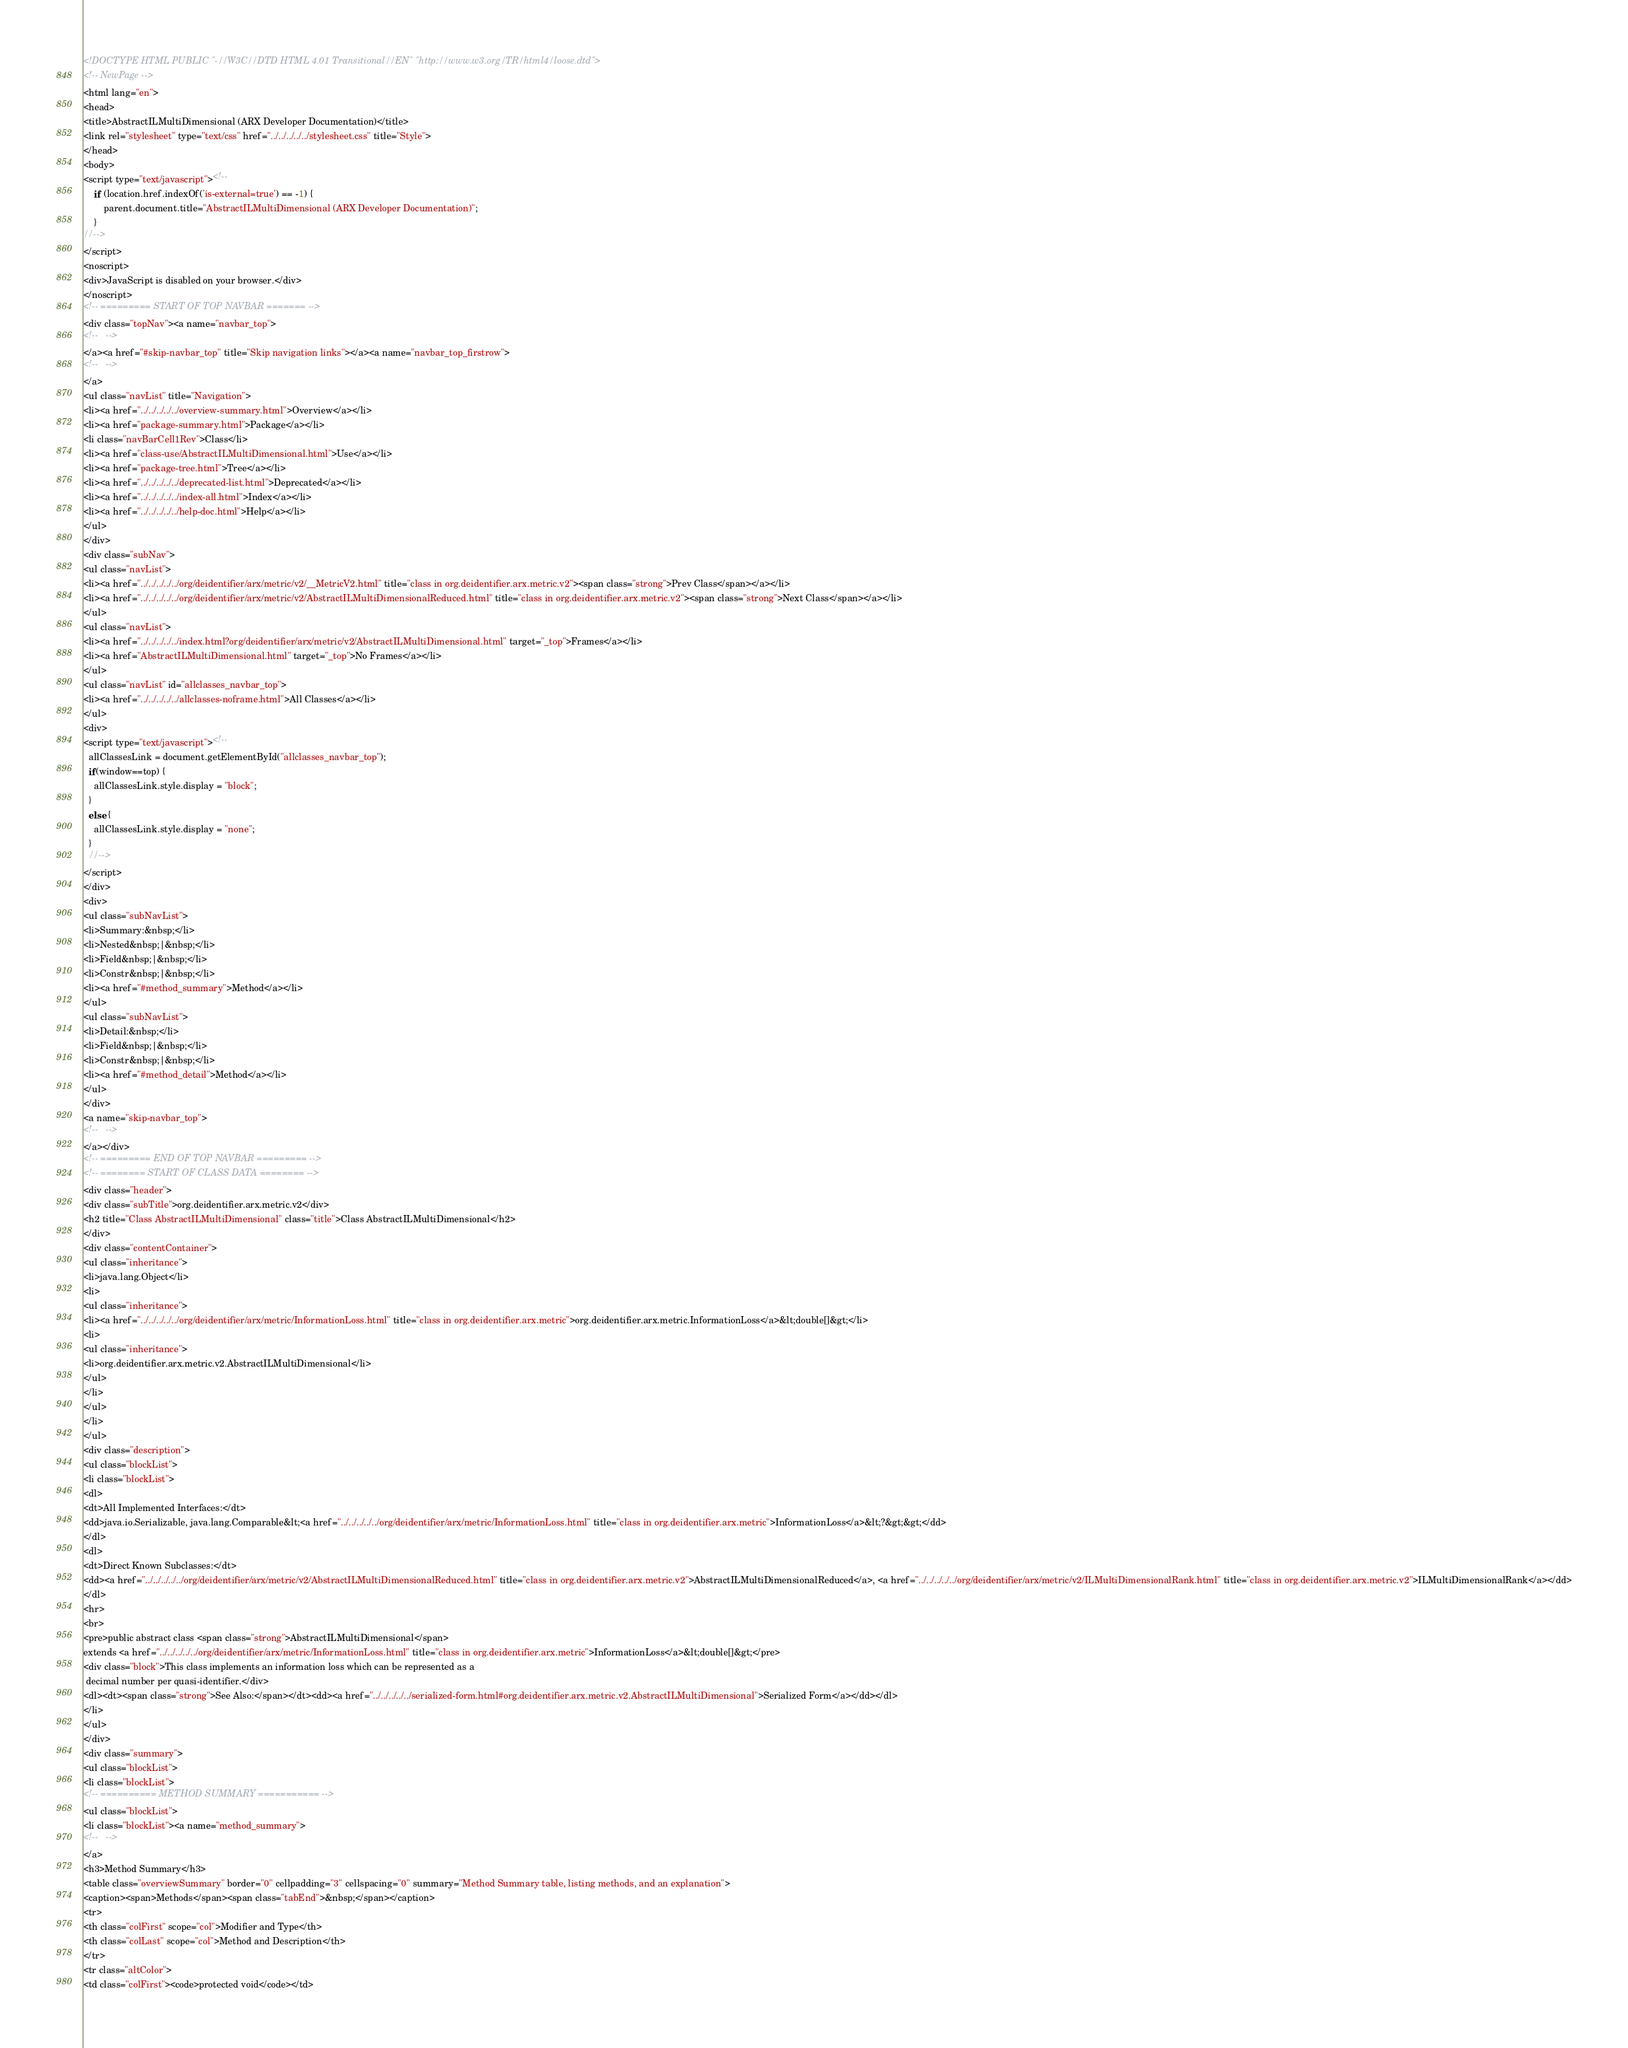<code> <loc_0><loc_0><loc_500><loc_500><_HTML_><!DOCTYPE HTML PUBLIC "-//W3C//DTD HTML 4.01 Transitional//EN" "http://www.w3.org/TR/html4/loose.dtd">
<!-- NewPage -->
<html lang="en">
<head>
<title>AbstractILMultiDimensional (ARX Developer Documentation)</title>
<link rel="stylesheet" type="text/css" href="../../../../../stylesheet.css" title="Style">
</head>
<body>
<script type="text/javascript"><!--
    if (location.href.indexOf('is-external=true') == -1) {
        parent.document.title="AbstractILMultiDimensional (ARX Developer Documentation)";
    }
//-->
</script>
<noscript>
<div>JavaScript is disabled on your browser.</div>
</noscript>
<!-- ========= START OF TOP NAVBAR ======= -->
<div class="topNav"><a name="navbar_top">
<!--   -->
</a><a href="#skip-navbar_top" title="Skip navigation links"></a><a name="navbar_top_firstrow">
<!--   -->
</a>
<ul class="navList" title="Navigation">
<li><a href="../../../../../overview-summary.html">Overview</a></li>
<li><a href="package-summary.html">Package</a></li>
<li class="navBarCell1Rev">Class</li>
<li><a href="class-use/AbstractILMultiDimensional.html">Use</a></li>
<li><a href="package-tree.html">Tree</a></li>
<li><a href="../../../../../deprecated-list.html">Deprecated</a></li>
<li><a href="../../../../../index-all.html">Index</a></li>
<li><a href="../../../../../help-doc.html">Help</a></li>
</ul>
</div>
<div class="subNav">
<ul class="navList">
<li><a href="../../../../../org/deidentifier/arx/metric/v2/__MetricV2.html" title="class in org.deidentifier.arx.metric.v2"><span class="strong">Prev Class</span></a></li>
<li><a href="../../../../../org/deidentifier/arx/metric/v2/AbstractILMultiDimensionalReduced.html" title="class in org.deidentifier.arx.metric.v2"><span class="strong">Next Class</span></a></li>
</ul>
<ul class="navList">
<li><a href="../../../../../index.html?org/deidentifier/arx/metric/v2/AbstractILMultiDimensional.html" target="_top">Frames</a></li>
<li><a href="AbstractILMultiDimensional.html" target="_top">No Frames</a></li>
</ul>
<ul class="navList" id="allclasses_navbar_top">
<li><a href="../../../../../allclasses-noframe.html">All Classes</a></li>
</ul>
<div>
<script type="text/javascript"><!--
  allClassesLink = document.getElementById("allclasses_navbar_top");
  if(window==top) {
    allClassesLink.style.display = "block";
  }
  else {
    allClassesLink.style.display = "none";
  }
  //-->
</script>
</div>
<div>
<ul class="subNavList">
<li>Summary:&nbsp;</li>
<li>Nested&nbsp;|&nbsp;</li>
<li>Field&nbsp;|&nbsp;</li>
<li>Constr&nbsp;|&nbsp;</li>
<li><a href="#method_summary">Method</a></li>
</ul>
<ul class="subNavList">
<li>Detail:&nbsp;</li>
<li>Field&nbsp;|&nbsp;</li>
<li>Constr&nbsp;|&nbsp;</li>
<li><a href="#method_detail">Method</a></li>
</ul>
</div>
<a name="skip-navbar_top">
<!--   -->
</a></div>
<!-- ========= END OF TOP NAVBAR ========= -->
<!-- ======== START OF CLASS DATA ======== -->
<div class="header">
<div class="subTitle">org.deidentifier.arx.metric.v2</div>
<h2 title="Class AbstractILMultiDimensional" class="title">Class AbstractILMultiDimensional</h2>
</div>
<div class="contentContainer">
<ul class="inheritance">
<li>java.lang.Object</li>
<li>
<ul class="inheritance">
<li><a href="../../../../../org/deidentifier/arx/metric/InformationLoss.html" title="class in org.deidentifier.arx.metric">org.deidentifier.arx.metric.InformationLoss</a>&lt;double[]&gt;</li>
<li>
<ul class="inheritance">
<li>org.deidentifier.arx.metric.v2.AbstractILMultiDimensional</li>
</ul>
</li>
</ul>
</li>
</ul>
<div class="description">
<ul class="blockList">
<li class="blockList">
<dl>
<dt>All Implemented Interfaces:</dt>
<dd>java.io.Serializable, java.lang.Comparable&lt;<a href="../../../../../org/deidentifier/arx/metric/InformationLoss.html" title="class in org.deidentifier.arx.metric">InformationLoss</a>&lt;?&gt;&gt;</dd>
</dl>
<dl>
<dt>Direct Known Subclasses:</dt>
<dd><a href="../../../../../org/deidentifier/arx/metric/v2/AbstractILMultiDimensionalReduced.html" title="class in org.deidentifier.arx.metric.v2">AbstractILMultiDimensionalReduced</a>, <a href="../../../../../org/deidentifier/arx/metric/v2/ILMultiDimensionalRank.html" title="class in org.deidentifier.arx.metric.v2">ILMultiDimensionalRank</a></dd>
</dl>
<hr>
<br>
<pre>public abstract class <span class="strong">AbstractILMultiDimensional</span>
extends <a href="../../../../../org/deidentifier/arx/metric/InformationLoss.html" title="class in org.deidentifier.arx.metric">InformationLoss</a>&lt;double[]&gt;</pre>
<div class="block">This class implements an information loss which can be represented as a
 decimal number per quasi-identifier.</div>
<dl><dt><span class="strong">See Also:</span></dt><dd><a href="../../../../../serialized-form.html#org.deidentifier.arx.metric.v2.AbstractILMultiDimensional">Serialized Form</a></dd></dl>
</li>
</ul>
</div>
<div class="summary">
<ul class="blockList">
<li class="blockList">
<!-- ========== METHOD SUMMARY =========== -->
<ul class="blockList">
<li class="blockList"><a name="method_summary">
<!--   -->
</a>
<h3>Method Summary</h3>
<table class="overviewSummary" border="0" cellpadding="3" cellspacing="0" summary="Method Summary table, listing methods, and an explanation">
<caption><span>Methods</span><span class="tabEnd">&nbsp;</span></caption>
<tr>
<th class="colFirst" scope="col">Modifier and Type</th>
<th class="colLast" scope="col">Method and Description</th>
</tr>
<tr class="altColor">
<td class="colFirst"><code>protected void</code></td></code> 